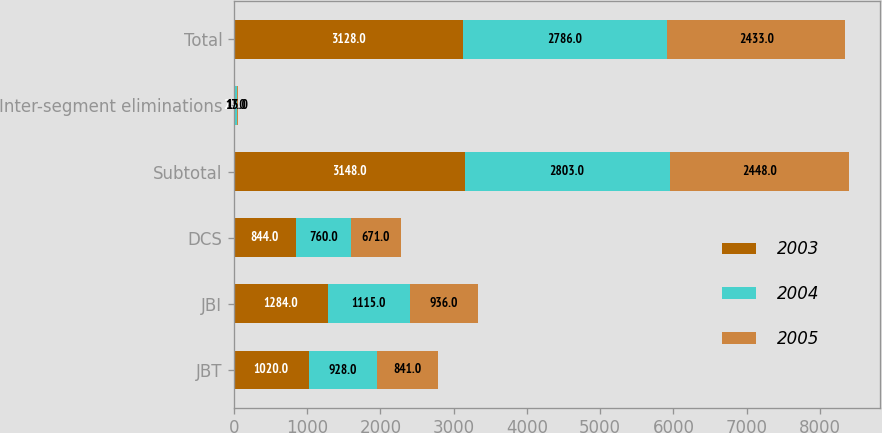Convert chart to OTSL. <chart><loc_0><loc_0><loc_500><loc_500><stacked_bar_chart><ecel><fcel>JBT<fcel>JBI<fcel>DCS<fcel>Subtotal<fcel>Inter-segment eliminations<fcel>Total<nl><fcel>2003<fcel>1020<fcel>1284<fcel>844<fcel>3148<fcel>20<fcel>3128<nl><fcel>2004<fcel>928<fcel>1115<fcel>760<fcel>2803<fcel>17<fcel>2786<nl><fcel>2005<fcel>841<fcel>936<fcel>671<fcel>2448<fcel>15<fcel>2433<nl></chart> 